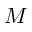Convert formula to latex. <formula><loc_0><loc_0><loc_500><loc_500>M</formula> 